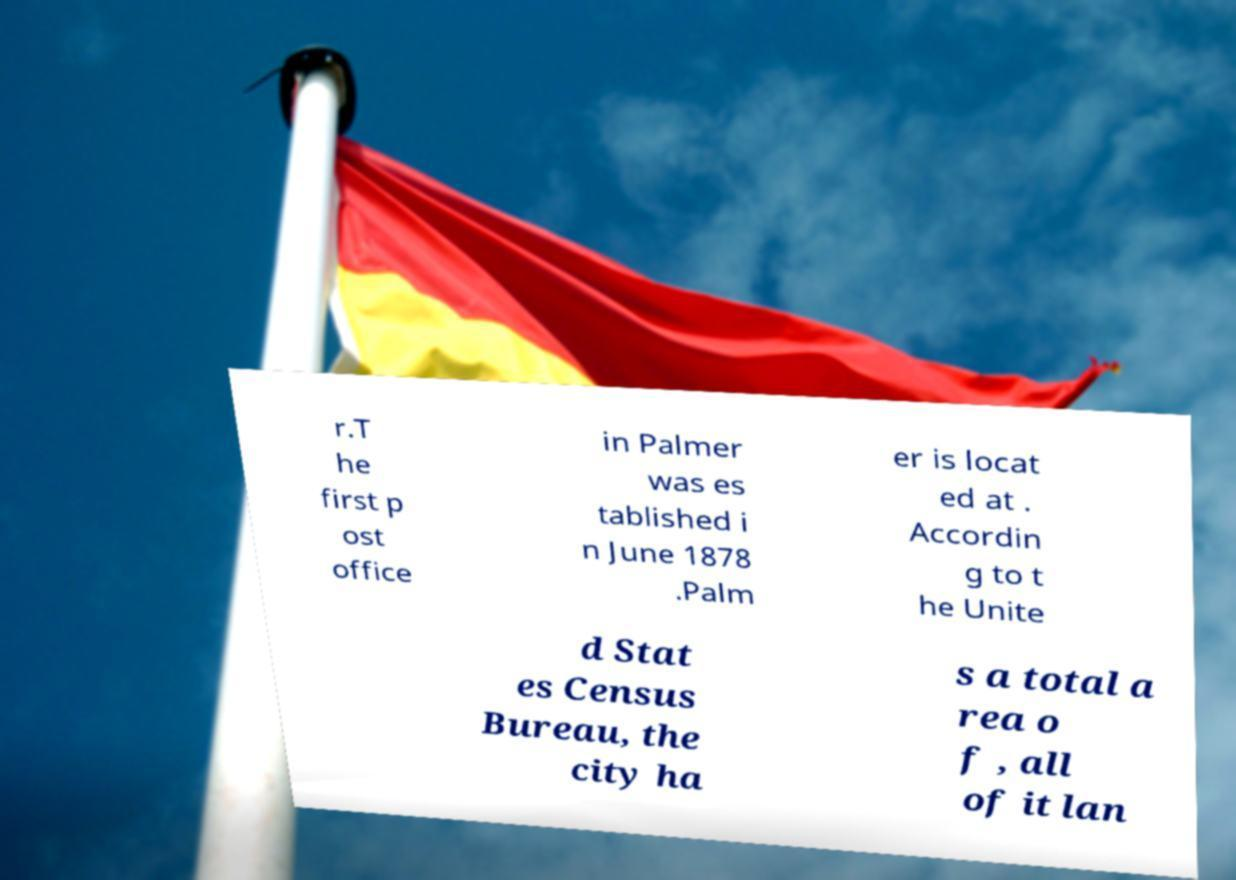Can you accurately transcribe the text from the provided image for me? r.T he first p ost office in Palmer was es tablished i n June 1878 .Palm er is locat ed at . Accordin g to t he Unite d Stat es Census Bureau, the city ha s a total a rea o f , all of it lan 